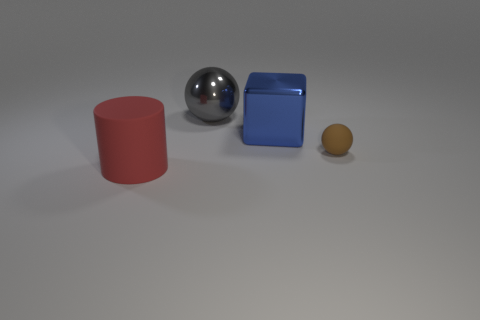There is a blue block that is left of the matte thing behind the big red matte cylinder on the left side of the big shiny sphere; what is its material?
Give a very brief answer. Metal. What number of other things are there of the same material as the big gray object
Make the answer very short. 1. How many tiny rubber things are behind the metal thing left of the big metal cube?
Your answer should be very brief. 0. What number of cylinders are either metal objects or big red rubber things?
Your answer should be compact. 1. The thing that is both to the right of the red object and in front of the big blue object is what color?
Your response must be concise. Brown. Are there any other things of the same color as the block?
Provide a short and direct response. No. The big shiny object in front of the ball that is behind the small object is what color?
Your answer should be very brief. Blue. Is the size of the cylinder the same as the brown sphere?
Keep it short and to the point. No. Is the sphere that is in front of the gray metal sphere made of the same material as the thing left of the gray sphere?
Ensure brevity in your answer.  Yes. The matte thing on the left side of the rubber thing on the right side of the thing that is left of the gray shiny object is what shape?
Provide a short and direct response. Cylinder. 